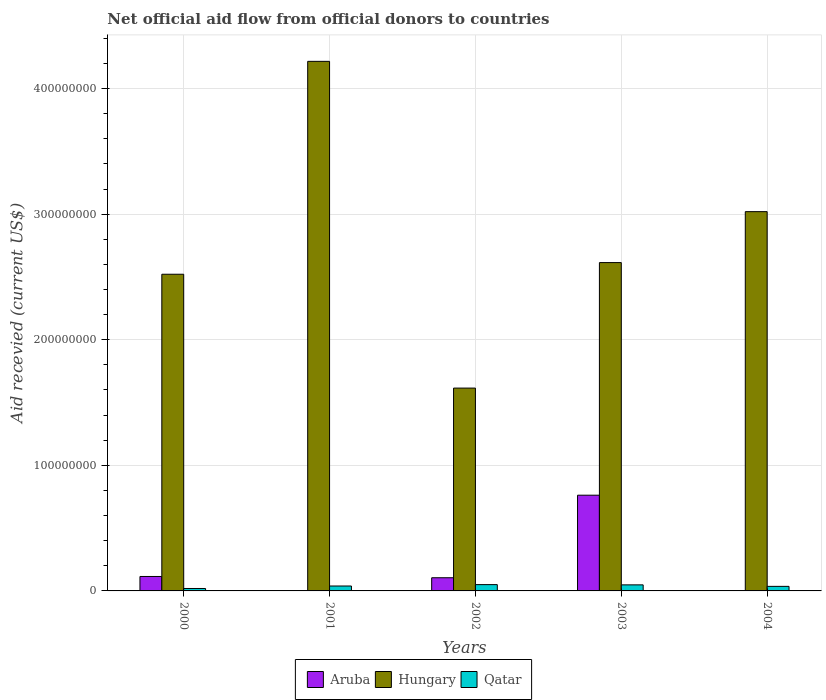Are the number of bars per tick equal to the number of legend labels?
Provide a short and direct response. No. In how many cases, is the number of bars for a given year not equal to the number of legend labels?
Offer a terse response. 2. What is the total aid received in Qatar in 2002?
Provide a succinct answer. 5.02e+06. Across all years, what is the maximum total aid received in Hungary?
Your response must be concise. 4.22e+08. Across all years, what is the minimum total aid received in Aruba?
Ensure brevity in your answer.  0. What is the total total aid received in Hungary in the graph?
Give a very brief answer. 1.40e+09. What is the difference between the total aid received in Hungary in 2002 and that in 2004?
Your answer should be compact. -1.40e+08. What is the difference between the total aid received in Hungary in 2003 and the total aid received in Aruba in 2001?
Offer a very short reply. 2.61e+08. What is the average total aid received in Aruba per year?
Your answer should be very brief. 1.96e+07. In the year 2003, what is the difference between the total aid received in Hungary and total aid received in Aruba?
Give a very brief answer. 1.85e+08. In how many years, is the total aid received in Qatar greater than 300000000 US$?
Make the answer very short. 0. What is the ratio of the total aid received in Qatar in 2000 to that in 2001?
Offer a terse response. 0.5. Is the total aid received in Qatar in 2002 less than that in 2003?
Provide a succinct answer. No. Is the difference between the total aid received in Hungary in 2002 and 2003 greater than the difference between the total aid received in Aruba in 2002 and 2003?
Keep it short and to the point. No. What is the difference between the highest and the second highest total aid received in Hungary?
Provide a succinct answer. 1.20e+08. What is the difference between the highest and the lowest total aid received in Hungary?
Your response must be concise. 2.60e+08. Is the sum of the total aid received in Hungary in 2001 and 2002 greater than the maximum total aid received in Aruba across all years?
Ensure brevity in your answer.  Yes. Is it the case that in every year, the sum of the total aid received in Qatar and total aid received in Aruba is greater than the total aid received in Hungary?
Make the answer very short. No. Are all the bars in the graph horizontal?
Provide a succinct answer. No. What is the difference between two consecutive major ticks on the Y-axis?
Provide a short and direct response. 1.00e+08. Does the graph contain grids?
Your response must be concise. Yes. What is the title of the graph?
Provide a short and direct response. Net official aid flow from official donors to countries. Does "Curacao" appear as one of the legend labels in the graph?
Your answer should be compact. No. What is the label or title of the Y-axis?
Give a very brief answer. Aid recevied (current US$). What is the Aid recevied (current US$) in Aruba in 2000?
Ensure brevity in your answer.  1.15e+07. What is the Aid recevied (current US$) of Hungary in 2000?
Provide a succinct answer. 2.52e+08. What is the Aid recevied (current US$) in Qatar in 2000?
Give a very brief answer. 1.94e+06. What is the Aid recevied (current US$) in Aruba in 2001?
Provide a succinct answer. 0. What is the Aid recevied (current US$) in Hungary in 2001?
Your response must be concise. 4.22e+08. What is the Aid recevied (current US$) of Qatar in 2001?
Your response must be concise. 3.91e+06. What is the Aid recevied (current US$) in Aruba in 2002?
Provide a succinct answer. 1.05e+07. What is the Aid recevied (current US$) of Hungary in 2002?
Offer a terse response. 1.62e+08. What is the Aid recevied (current US$) in Qatar in 2002?
Offer a very short reply. 5.02e+06. What is the Aid recevied (current US$) in Aruba in 2003?
Your answer should be compact. 7.62e+07. What is the Aid recevied (current US$) in Hungary in 2003?
Your answer should be compact. 2.61e+08. What is the Aid recevied (current US$) of Qatar in 2003?
Provide a short and direct response. 4.82e+06. What is the Aid recevied (current US$) of Hungary in 2004?
Offer a very short reply. 3.02e+08. What is the Aid recevied (current US$) of Qatar in 2004?
Your response must be concise. 3.63e+06. Across all years, what is the maximum Aid recevied (current US$) in Aruba?
Provide a short and direct response. 7.62e+07. Across all years, what is the maximum Aid recevied (current US$) of Hungary?
Offer a very short reply. 4.22e+08. Across all years, what is the maximum Aid recevied (current US$) in Qatar?
Give a very brief answer. 5.02e+06. Across all years, what is the minimum Aid recevied (current US$) in Hungary?
Your answer should be compact. 1.62e+08. Across all years, what is the minimum Aid recevied (current US$) of Qatar?
Your answer should be very brief. 1.94e+06. What is the total Aid recevied (current US$) of Aruba in the graph?
Provide a short and direct response. 9.82e+07. What is the total Aid recevied (current US$) in Hungary in the graph?
Provide a succinct answer. 1.40e+09. What is the total Aid recevied (current US$) in Qatar in the graph?
Keep it short and to the point. 1.93e+07. What is the difference between the Aid recevied (current US$) in Hungary in 2000 and that in 2001?
Provide a short and direct response. -1.70e+08. What is the difference between the Aid recevied (current US$) of Qatar in 2000 and that in 2001?
Keep it short and to the point. -1.97e+06. What is the difference between the Aid recevied (current US$) in Aruba in 2000 and that in 2002?
Make the answer very short. 1.01e+06. What is the difference between the Aid recevied (current US$) in Hungary in 2000 and that in 2002?
Your answer should be very brief. 9.06e+07. What is the difference between the Aid recevied (current US$) of Qatar in 2000 and that in 2002?
Provide a short and direct response. -3.08e+06. What is the difference between the Aid recevied (current US$) of Aruba in 2000 and that in 2003?
Your answer should be very brief. -6.47e+07. What is the difference between the Aid recevied (current US$) of Hungary in 2000 and that in 2003?
Provide a succinct answer. -9.28e+06. What is the difference between the Aid recevied (current US$) of Qatar in 2000 and that in 2003?
Offer a very short reply. -2.88e+06. What is the difference between the Aid recevied (current US$) of Hungary in 2000 and that in 2004?
Your response must be concise. -4.98e+07. What is the difference between the Aid recevied (current US$) in Qatar in 2000 and that in 2004?
Offer a terse response. -1.69e+06. What is the difference between the Aid recevied (current US$) of Hungary in 2001 and that in 2002?
Provide a short and direct response. 2.60e+08. What is the difference between the Aid recevied (current US$) of Qatar in 2001 and that in 2002?
Give a very brief answer. -1.11e+06. What is the difference between the Aid recevied (current US$) in Hungary in 2001 and that in 2003?
Give a very brief answer. 1.60e+08. What is the difference between the Aid recevied (current US$) of Qatar in 2001 and that in 2003?
Offer a terse response. -9.10e+05. What is the difference between the Aid recevied (current US$) of Hungary in 2001 and that in 2004?
Your answer should be very brief. 1.20e+08. What is the difference between the Aid recevied (current US$) of Qatar in 2001 and that in 2004?
Provide a short and direct response. 2.80e+05. What is the difference between the Aid recevied (current US$) in Aruba in 2002 and that in 2003?
Offer a very short reply. -6.57e+07. What is the difference between the Aid recevied (current US$) in Hungary in 2002 and that in 2003?
Your answer should be very brief. -9.99e+07. What is the difference between the Aid recevied (current US$) in Hungary in 2002 and that in 2004?
Provide a succinct answer. -1.40e+08. What is the difference between the Aid recevied (current US$) of Qatar in 2002 and that in 2004?
Give a very brief answer. 1.39e+06. What is the difference between the Aid recevied (current US$) of Hungary in 2003 and that in 2004?
Make the answer very short. -4.06e+07. What is the difference between the Aid recevied (current US$) of Qatar in 2003 and that in 2004?
Make the answer very short. 1.19e+06. What is the difference between the Aid recevied (current US$) of Aruba in 2000 and the Aid recevied (current US$) of Hungary in 2001?
Keep it short and to the point. -4.10e+08. What is the difference between the Aid recevied (current US$) of Aruba in 2000 and the Aid recevied (current US$) of Qatar in 2001?
Give a very brief answer. 7.59e+06. What is the difference between the Aid recevied (current US$) in Hungary in 2000 and the Aid recevied (current US$) in Qatar in 2001?
Provide a succinct answer. 2.48e+08. What is the difference between the Aid recevied (current US$) of Aruba in 2000 and the Aid recevied (current US$) of Hungary in 2002?
Provide a succinct answer. -1.50e+08. What is the difference between the Aid recevied (current US$) of Aruba in 2000 and the Aid recevied (current US$) of Qatar in 2002?
Offer a terse response. 6.48e+06. What is the difference between the Aid recevied (current US$) of Hungary in 2000 and the Aid recevied (current US$) of Qatar in 2002?
Offer a terse response. 2.47e+08. What is the difference between the Aid recevied (current US$) of Aruba in 2000 and the Aid recevied (current US$) of Hungary in 2003?
Your answer should be compact. -2.50e+08. What is the difference between the Aid recevied (current US$) of Aruba in 2000 and the Aid recevied (current US$) of Qatar in 2003?
Your answer should be very brief. 6.68e+06. What is the difference between the Aid recevied (current US$) of Hungary in 2000 and the Aid recevied (current US$) of Qatar in 2003?
Your answer should be very brief. 2.47e+08. What is the difference between the Aid recevied (current US$) in Aruba in 2000 and the Aid recevied (current US$) in Hungary in 2004?
Offer a terse response. -2.91e+08. What is the difference between the Aid recevied (current US$) in Aruba in 2000 and the Aid recevied (current US$) in Qatar in 2004?
Give a very brief answer. 7.87e+06. What is the difference between the Aid recevied (current US$) of Hungary in 2000 and the Aid recevied (current US$) of Qatar in 2004?
Provide a short and direct response. 2.49e+08. What is the difference between the Aid recevied (current US$) of Hungary in 2001 and the Aid recevied (current US$) of Qatar in 2002?
Offer a very short reply. 4.17e+08. What is the difference between the Aid recevied (current US$) in Hungary in 2001 and the Aid recevied (current US$) in Qatar in 2003?
Provide a succinct answer. 4.17e+08. What is the difference between the Aid recevied (current US$) of Hungary in 2001 and the Aid recevied (current US$) of Qatar in 2004?
Offer a terse response. 4.18e+08. What is the difference between the Aid recevied (current US$) in Aruba in 2002 and the Aid recevied (current US$) in Hungary in 2003?
Your response must be concise. -2.51e+08. What is the difference between the Aid recevied (current US$) in Aruba in 2002 and the Aid recevied (current US$) in Qatar in 2003?
Offer a very short reply. 5.67e+06. What is the difference between the Aid recevied (current US$) in Hungary in 2002 and the Aid recevied (current US$) in Qatar in 2003?
Provide a short and direct response. 1.57e+08. What is the difference between the Aid recevied (current US$) in Aruba in 2002 and the Aid recevied (current US$) in Hungary in 2004?
Ensure brevity in your answer.  -2.92e+08. What is the difference between the Aid recevied (current US$) of Aruba in 2002 and the Aid recevied (current US$) of Qatar in 2004?
Your answer should be very brief. 6.86e+06. What is the difference between the Aid recevied (current US$) of Hungary in 2002 and the Aid recevied (current US$) of Qatar in 2004?
Your response must be concise. 1.58e+08. What is the difference between the Aid recevied (current US$) in Aruba in 2003 and the Aid recevied (current US$) in Hungary in 2004?
Your response must be concise. -2.26e+08. What is the difference between the Aid recevied (current US$) in Aruba in 2003 and the Aid recevied (current US$) in Qatar in 2004?
Provide a succinct answer. 7.26e+07. What is the difference between the Aid recevied (current US$) in Hungary in 2003 and the Aid recevied (current US$) in Qatar in 2004?
Give a very brief answer. 2.58e+08. What is the average Aid recevied (current US$) in Aruba per year?
Provide a succinct answer. 1.96e+07. What is the average Aid recevied (current US$) of Hungary per year?
Offer a very short reply. 2.80e+08. What is the average Aid recevied (current US$) in Qatar per year?
Keep it short and to the point. 3.86e+06. In the year 2000, what is the difference between the Aid recevied (current US$) of Aruba and Aid recevied (current US$) of Hungary?
Provide a succinct answer. -2.41e+08. In the year 2000, what is the difference between the Aid recevied (current US$) of Aruba and Aid recevied (current US$) of Qatar?
Give a very brief answer. 9.56e+06. In the year 2000, what is the difference between the Aid recevied (current US$) of Hungary and Aid recevied (current US$) of Qatar?
Make the answer very short. 2.50e+08. In the year 2001, what is the difference between the Aid recevied (current US$) of Hungary and Aid recevied (current US$) of Qatar?
Give a very brief answer. 4.18e+08. In the year 2002, what is the difference between the Aid recevied (current US$) in Aruba and Aid recevied (current US$) in Hungary?
Your response must be concise. -1.51e+08. In the year 2002, what is the difference between the Aid recevied (current US$) in Aruba and Aid recevied (current US$) in Qatar?
Your answer should be compact. 5.47e+06. In the year 2002, what is the difference between the Aid recevied (current US$) in Hungary and Aid recevied (current US$) in Qatar?
Make the answer very short. 1.56e+08. In the year 2003, what is the difference between the Aid recevied (current US$) in Aruba and Aid recevied (current US$) in Hungary?
Your response must be concise. -1.85e+08. In the year 2003, what is the difference between the Aid recevied (current US$) in Aruba and Aid recevied (current US$) in Qatar?
Offer a terse response. 7.14e+07. In the year 2003, what is the difference between the Aid recevied (current US$) in Hungary and Aid recevied (current US$) in Qatar?
Provide a succinct answer. 2.57e+08. In the year 2004, what is the difference between the Aid recevied (current US$) of Hungary and Aid recevied (current US$) of Qatar?
Ensure brevity in your answer.  2.98e+08. What is the ratio of the Aid recevied (current US$) of Hungary in 2000 to that in 2001?
Your answer should be very brief. 0.6. What is the ratio of the Aid recevied (current US$) in Qatar in 2000 to that in 2001?
Provide a short and direct response. 0.5. What is the ratio of the Aid recevied (current US$) of Aruba in 2000 to that in 2002?
Your answer should be compact. 1.1. What is the ratio of the Aid recevied (current US$) in Hungary in 2000 to that in 2002?
Provide a short and direct response. 1.56. What is the ratio of the Aid recevied (current US$) of Qatar in 2000 to that in 2002?
Make the answer very short. 0.39. What is the ratio of the Aid recevied (current US$) of Aruba in 2000 to that in 2003?
Offer a terse response. 0.15. What is the ratio of the Aid recevied (current US$) in Hungary in 2000 to that in 2003?
Offer a terse response. 0.96. What is the ratio of the Aid recevied (current US$) in Qatar in 2000 to that in 2003?
Offer a very short reply. 0.4. What is the ratio of the Aid recevied (current US$) of Hungary in 2000 to that in 2004?
Provide a short and direct response. 0.83. What is the ratio of the Aid recevied (current US$) of Qatar in 2000 to that in 2004?
Give a very brief answer. 0.53. What is the ratio of the Aid recevied (current US$) in Hungary in 2001 to that in 2002?
Your answer should be very brief. 2.61. What is the ratio of the Aid recevied (current US$) of Qatar in 2001 to that in 2002?
Offer a terse response. 0.78. What is the ratio of the Aid recevied (current US$) of Hungary in 2001 to that in 2003?
Provide a succinct answer. 1.61. What is the ratio of the Aid recevied (current US$) in Qatar in 2001 to that in 2003?
Offer a very short reply. 0.81. What is the ratio of the Aid recevied (current US$) of Hungary in 2001 to that in 2004?
Offer a very short reply. 1.4. What is the ratio of the Aid recevied (current US$) in Qatar in 2001 to that in 2004?
Offer a terse response. 1.08. What is the ratio of the Aid recevied (current US$) in Aruba in 2002 to that in 2003?
Ensure brevity in your answer.  0.14. What is the ratio of the Aid recevied (current US$) of Hungary in 2002 to that in 2003?
Provide a short and direct response. 0.62. What is the ratio of the Aid recevied (current US$) of Qatar in 2002 to that in 2003?
Give a very brief answer. 1.04. What is the ratio of the Aid recevied (current US$) of Hungary in 2002 to that in 2004?
Provide a succinct answer. 0.53. What is the ratio of the Aid recevied (current US$) in Qatar in 2002 to that in 2004?
Make the answer very short. 1.38. What is the ratio of the Aid recevied (current US$) in Hungary in 2003 to that in 2004?
Provide a succinct answer. 0.87. What is the ratio of the Aid recevied (current US$) of Qatar in 2003 to that in 2004?
Your answer should be very brief. 1.33. What is the difference between the highest and the second highest Aid recevied (current US$) of Aruba?
Offer a terse response. 6.47e+07. What is the difference between the highest and the second highest Aid recevied (current US$) in Hungary?
Ensure brevity in your answer.  1.20e+08. What is the difference between the highest and the lowest Aid recevied (current US$) of Aruba?
Offer a terse response. 7.62e+07. What is the difference between the highest and the lowest Aid recevied (current US$) in Hungary?
Offer a very short reply. 2.60e+08. What is the difference between the highest and the lowest Aid recevied (current US$) of Qatar?
Keep it short and to the point. 3.08e+06. 